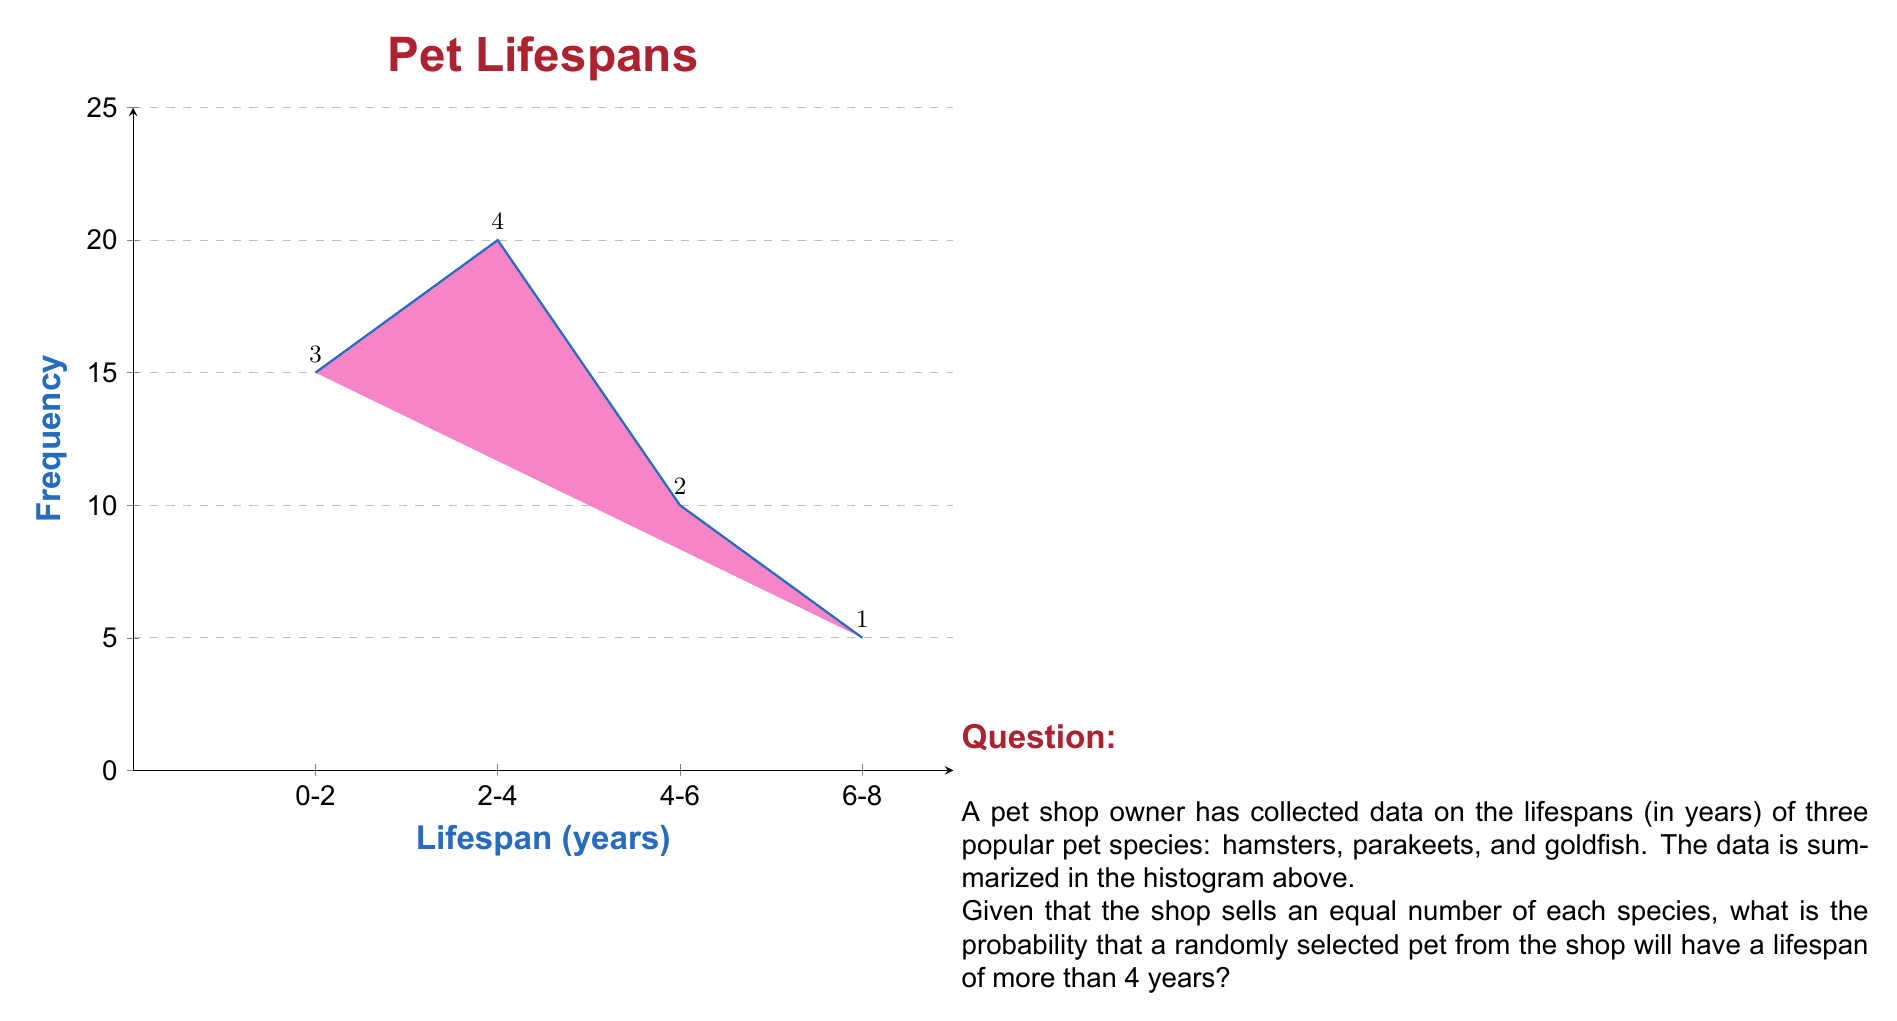Show me your answer to this math problem. To solve this problem, we need to follow these steps:

1) First, let's calculate the total number of pets in the sample:
   $$\text{Total} = 15 + 20 + 10 + 5 = 50\text{ pets}$$

2) Now, we need to determine how many pets have a lifespan of more than 4 years:
   $$\text{Pets living > 4 years} = 10 + 5 = 15\text{ pets}$$

3) The probability is calculated by dividing the number of favorable outcomes by the total number of possible outcomes:

   $$P(\text{lifespan > 4 years}) = \frac{\text{Pets living > 4 years}}{\text{Total pets}}$$

   $$P(\text{lifespan > 4 years}) = \frac{15}{50} = 0.3$$

4) We can express this as a percentage:
   $$0.3 \times 100\% = 30\%$$

Therefore, the probability that a randomly selected pet will have a lifespan of more than 4 years is 0.3 or 30%.
Answer: 0.3 or 30% 